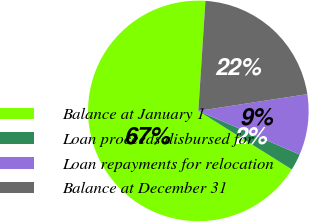Convert chart. <chart><loc_0><loc_0><loc_500><loc_500><pie_chart><fcel>Balance at January 1<fcel>Loan proceeds disbursed for<fcel>Loan repayments for relocation<fcel>Balance at December 31<nl><fcel>67.12%<fcel>2.43%<fcel>8.9%<fcel>21.55%<nl></chart> 